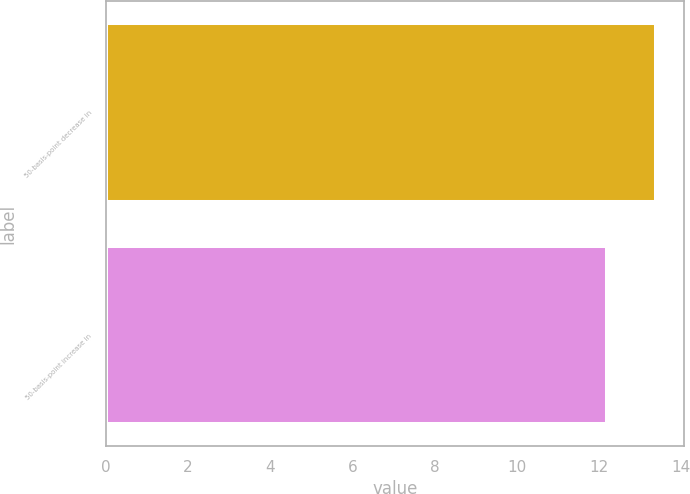<chart> <loc_0><loc_0><loc_500><loc_500><bar_chart><fcel>50-basis-point decrease in<fcel>50-basis-point increase in<nl><fcel>13.4<fcel>12.2<nl></chart> 